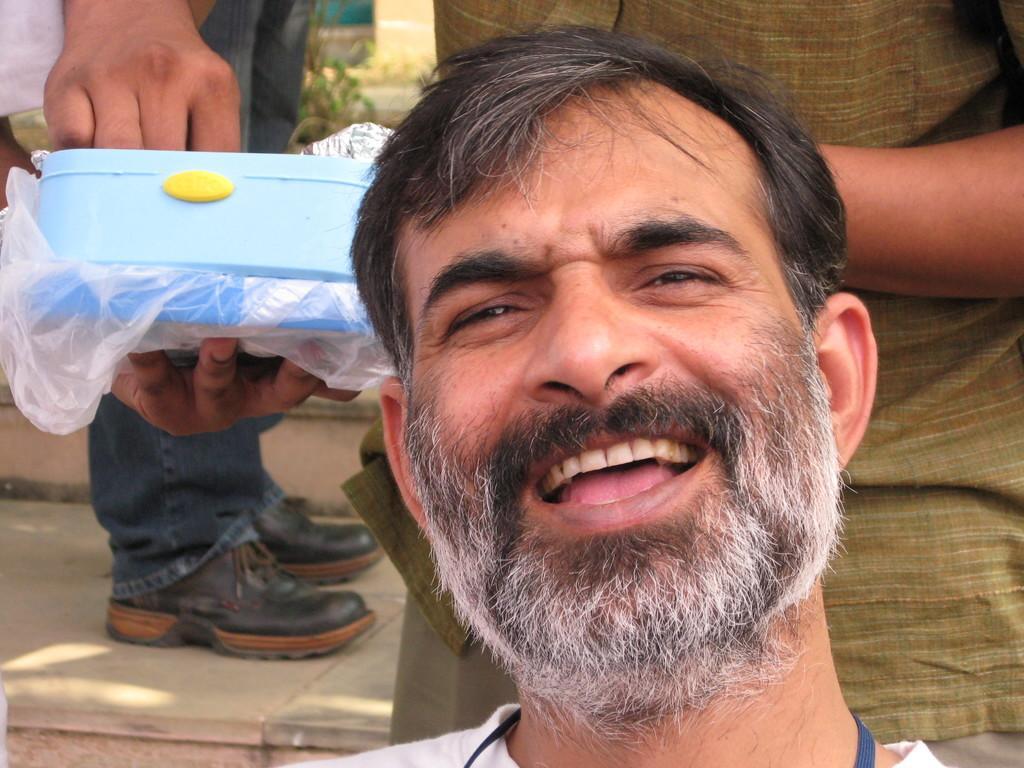Can you describe this image briefly? Here in this picture we can see a person smiling and behind him also we can see other persons standing and one person is holding a box in his hand and we can also see plants on the ground in blurry manner. 